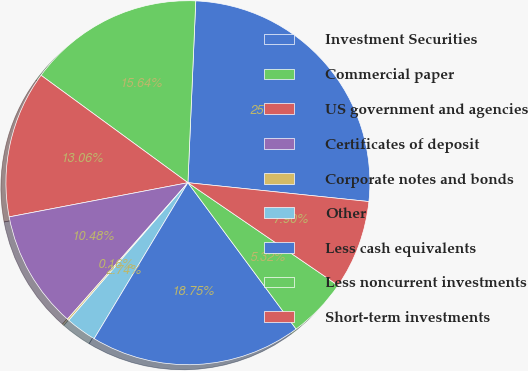Convert chart. <chart><loc_0><loc_0><loc_500><loc_500><pie_chart><fcel>Investment Securities<fcel>Commercial paper<fcel>US government and agencies<fcel>Certificates of deposit<fcel>Corporate notes and bonds<fcel>Other<fcel>Less cash equivalents<fcel>Less noncurrent investments<fcel>Short-term investments<nl><fcel>25.97%<fcel>15.64%<fcel>13.06%<fcel>10.48%<fcel>0.16%<fcel>2.74%<fcel>18.75%<fcel>5.32%<fcel>7.9%<nl></chart> 